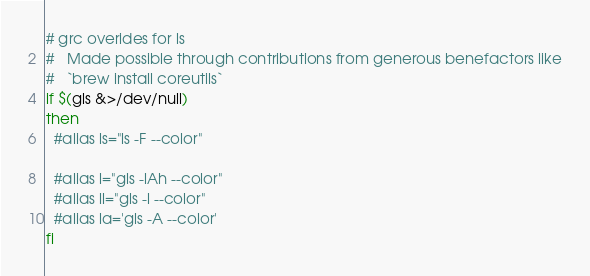<code> <loc_0><loc_0><loc_500><loc_500><_Bash_># grc overides for ls
#   Made possible through contributions from generous benefactors like
#   `brew install coreutils`
if $(gls &>/dev/null)
then
  #alias ls="ls -F --color"

  #alias l="gls -lAh --color"
  #alias ll="gls -l --color"
  #alias la='gls -A --color'
fi
</code> 